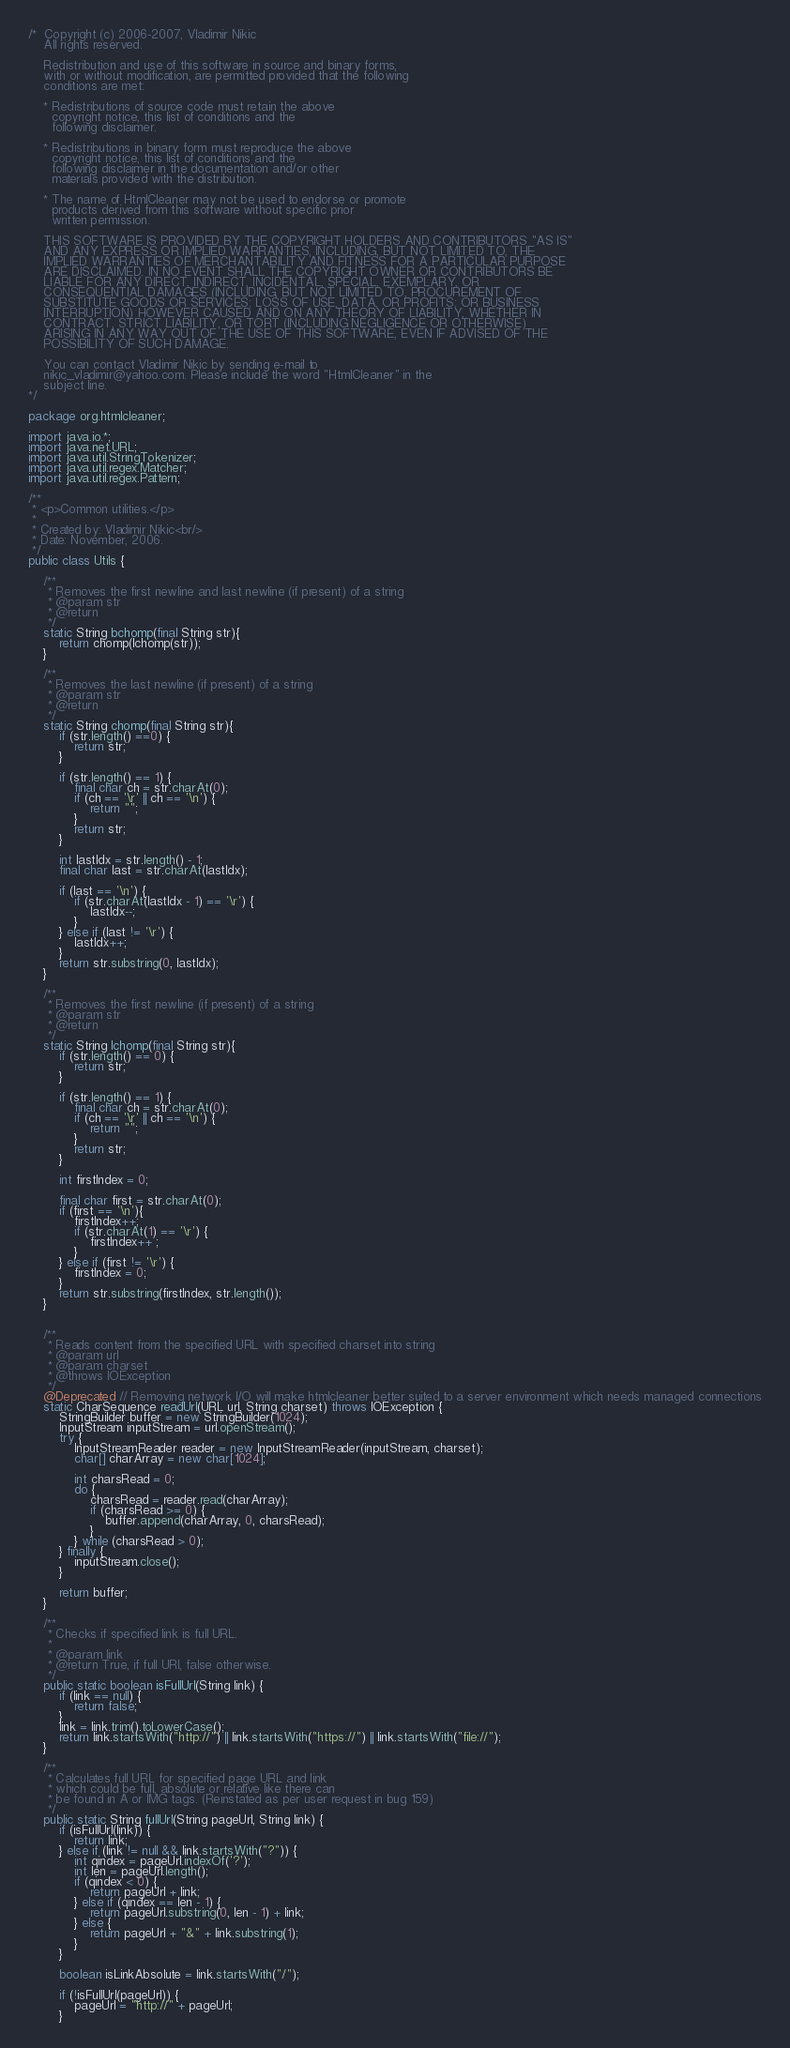<code> <loc_0><loc_0><loc_500><loc_500><_Java_>/*  Copyright (c) 2006-2007, Vladimir Nikic
    All rights reserved.

    Redistribution and use of this software in source and binary forms,
    with or without modification, are permitted provided that the following
    conditions are met:

    * Redistributions of source code must retain the above
      copyright notice, this list of conditions and the
      following disclaimer.

    * Redistributions in binary form must reproduce the above
      copyright notice, this list of conditions and the
      following disclaimer in the documentation and/or other
      materials provided with the distribution.

    * The name of HtmlCleaner may not be used to endorse or promote
      products derived from this software without specific prior
      written permission.

    THIS SOFTWARE IS PROVIDED BY THE COPYRIGHT HOLDERS AND CONTRIBUTORS "AS IS"
    AND ANY EXPRESS OR IMPLIED WARRANTIES, INCLUDING, BUT NOT LIMITED TO, THE
    IMPLIED WARRANTIES OF MERCHANTABILITY AND FITNESS FOR A PARTICULAR PURPOSE
    ARE DISCLAIMED. IN NO EVENT SHALL THE COPYRIGHT OWNER OR CONTRIBUTORS BE
    LIABLE FOR ANY DIRECT, INDIRECT, INCIDENTAL, SPECIAL, EXEMPLARY, OR
    CONSEQUENTIAL DAMAGES (INCLUDING, BUT NOT LIMITED TO, PROCUREMENT OF
    SUBSTITUTE GOODS OR SERVICES; LOSS OF USE, DATA, OR PROFITS; OR BUSINESS
    INTERRUPTION) HOWEVER CAUSED AND ON ANY THEORY OF LIABILITY, WHETHER IN
    CONTRACT, STRICT LIABILITY, OR TORT (INCLUDING NEGLIGENCE OR OTHERWISE)
    ARISING IN ANY WAY OUT OF THE USE OF THIS SOFTWARE, EVEN IF ADVISED OF THE
    POSSIBILITY OF SUCH DAMAGE.

    You can contact Vladimir Nikic by sending e-mail to
    nikic_vladimir@yahoo.com. Please include the word "HtmlCleaner" in the
    subject line.
*/

package org.htmlcleaner;

import java.io.*;
import java.net.URL;
import java.util.StringTokenizer;
import java.util.regex.Matcher;
import java.util.regex.Pattern;

/**
 * <p>Common utilities.</p>
 *
 * Created by: Vladimir Nikic<br/>
 * Date: November, 2006.
 */
public class Utils {
	
	/**
	 * Removes the first newline and last newline (if present) of a string
	 * @param str
	 * @return
	 */
	static String bchomp(final String str){
		return chomp(lchomp(str));
	}
	
	/**
	 * Removes the last newline (if present) of a string
	 * @param str
	 * @return
	 */
	static String chomp(final String str){
		if (str.length() ==0) {
			return str;
		}

		if (str.length() == 1) {
			final char ch = str.charAt(0);
			if (ch == '\r' || ch == '\n') {
				return "";
			}
			return str;
		}

		int lastIdx = str.length() - 1;
		final char last = str.charAt(lastIdx);

		if (last == '\n') {
			if (str.charAt(lastIdx - 1) == '\r') {
				lastIdx--;
			}
		} else if (last != '\r') {
			lastIdx++;
		}
		return str.substring(0, lastIdx);
	}
	
	/**
	 * Removes the first newline (if present) of a string
	 * @param str
	 * @return
	 */
	static String lchomp(final String str){
		if (str.length() == 0) {
			return str;
		}

		if (str.length() == 1) {
			final char ch = str.charAt(0);
			if (ch == '\r' || ch == '\n') {
				return "";
			}
			return str;
		}
		
		int firstIndex = 0;
		
		final char first = str.charAt(0);
		if (first == '\n'){
			firstIndex++;
			if (str.charAt(1) == '\r') {
				firstIndex++ ;
			}
		} else if (first != '\r') {
			firstIndex = 0;
		}
		return str.substring(firstIndex, str.length());
	}
	

    /**
     * Reads content from the specified URL with specified charset into string
     * @param url
     * @param charset
     * @throws IOException
     */
    @Deprecated // Removing network I/O will make htmlcleaner better suited to a server environment which needs managed connections
    static CharSequence readUrl(URL url, String charset) throws IOException {
        StringBuilder buffer = new StringBuilder(1024);
        InputStream inputStream = url.openStream();
        try {
            InputStreamReader reader = new InputStreamReader(inputStream, charset);
            char[] charArray = new char[1024];

            int charsRead = 0;
            do {
                charsRead = reader.read(charArray);
                if (charsRead >= 0) {
                    buffer.append(charArray, 0, charsRead);
                }
            } while (charsRead > 0);
        } finally {
            inputStream.close();
        }

        return buffer;
    }
    
    /**
     * Checks if specified link is full URL.
     *
     * @param link
     * @return True, if full URl, false otherwise.
     */
    public static boolean isFullUrl(String link) {
        if (link == null) {
            return false;
        }
        link = link.trim().toLowerCase();
        return link.startsWith("http://") || link.startsWith("https://") || link.startsWith("file://");
    }
    
    /**
     * Calculates full URL for specified page URL and link
     * which could be full, absolute or relative like there can
     * be found in A or IMG tags. (Reinstated as per user request in bug 159)
     */
    public static String fullUrl(String pageUrl, String link) {
        if (isFullUrl(link)) {
            return link;
        } else if (link != null && link.startsWith("?")) {
            int qindex = pageUrl.indexOf('?');
            int len = pageUrl.length();
            if (qindex < 0) {
                return pageUrl + link;
            } else if (qindex == len - 1) {
                return pageUrl.substring(0, len - 1) + link;
            } else {
                return pageUrl + "&" + link.substring(1);
            }
        }

        boolean isLinkAbsolute = link.startsWith("/");

        if (!isFullUrl(pageUrl)) {
            pageUrl = "http://" + pageUrl;
        }
</code> 